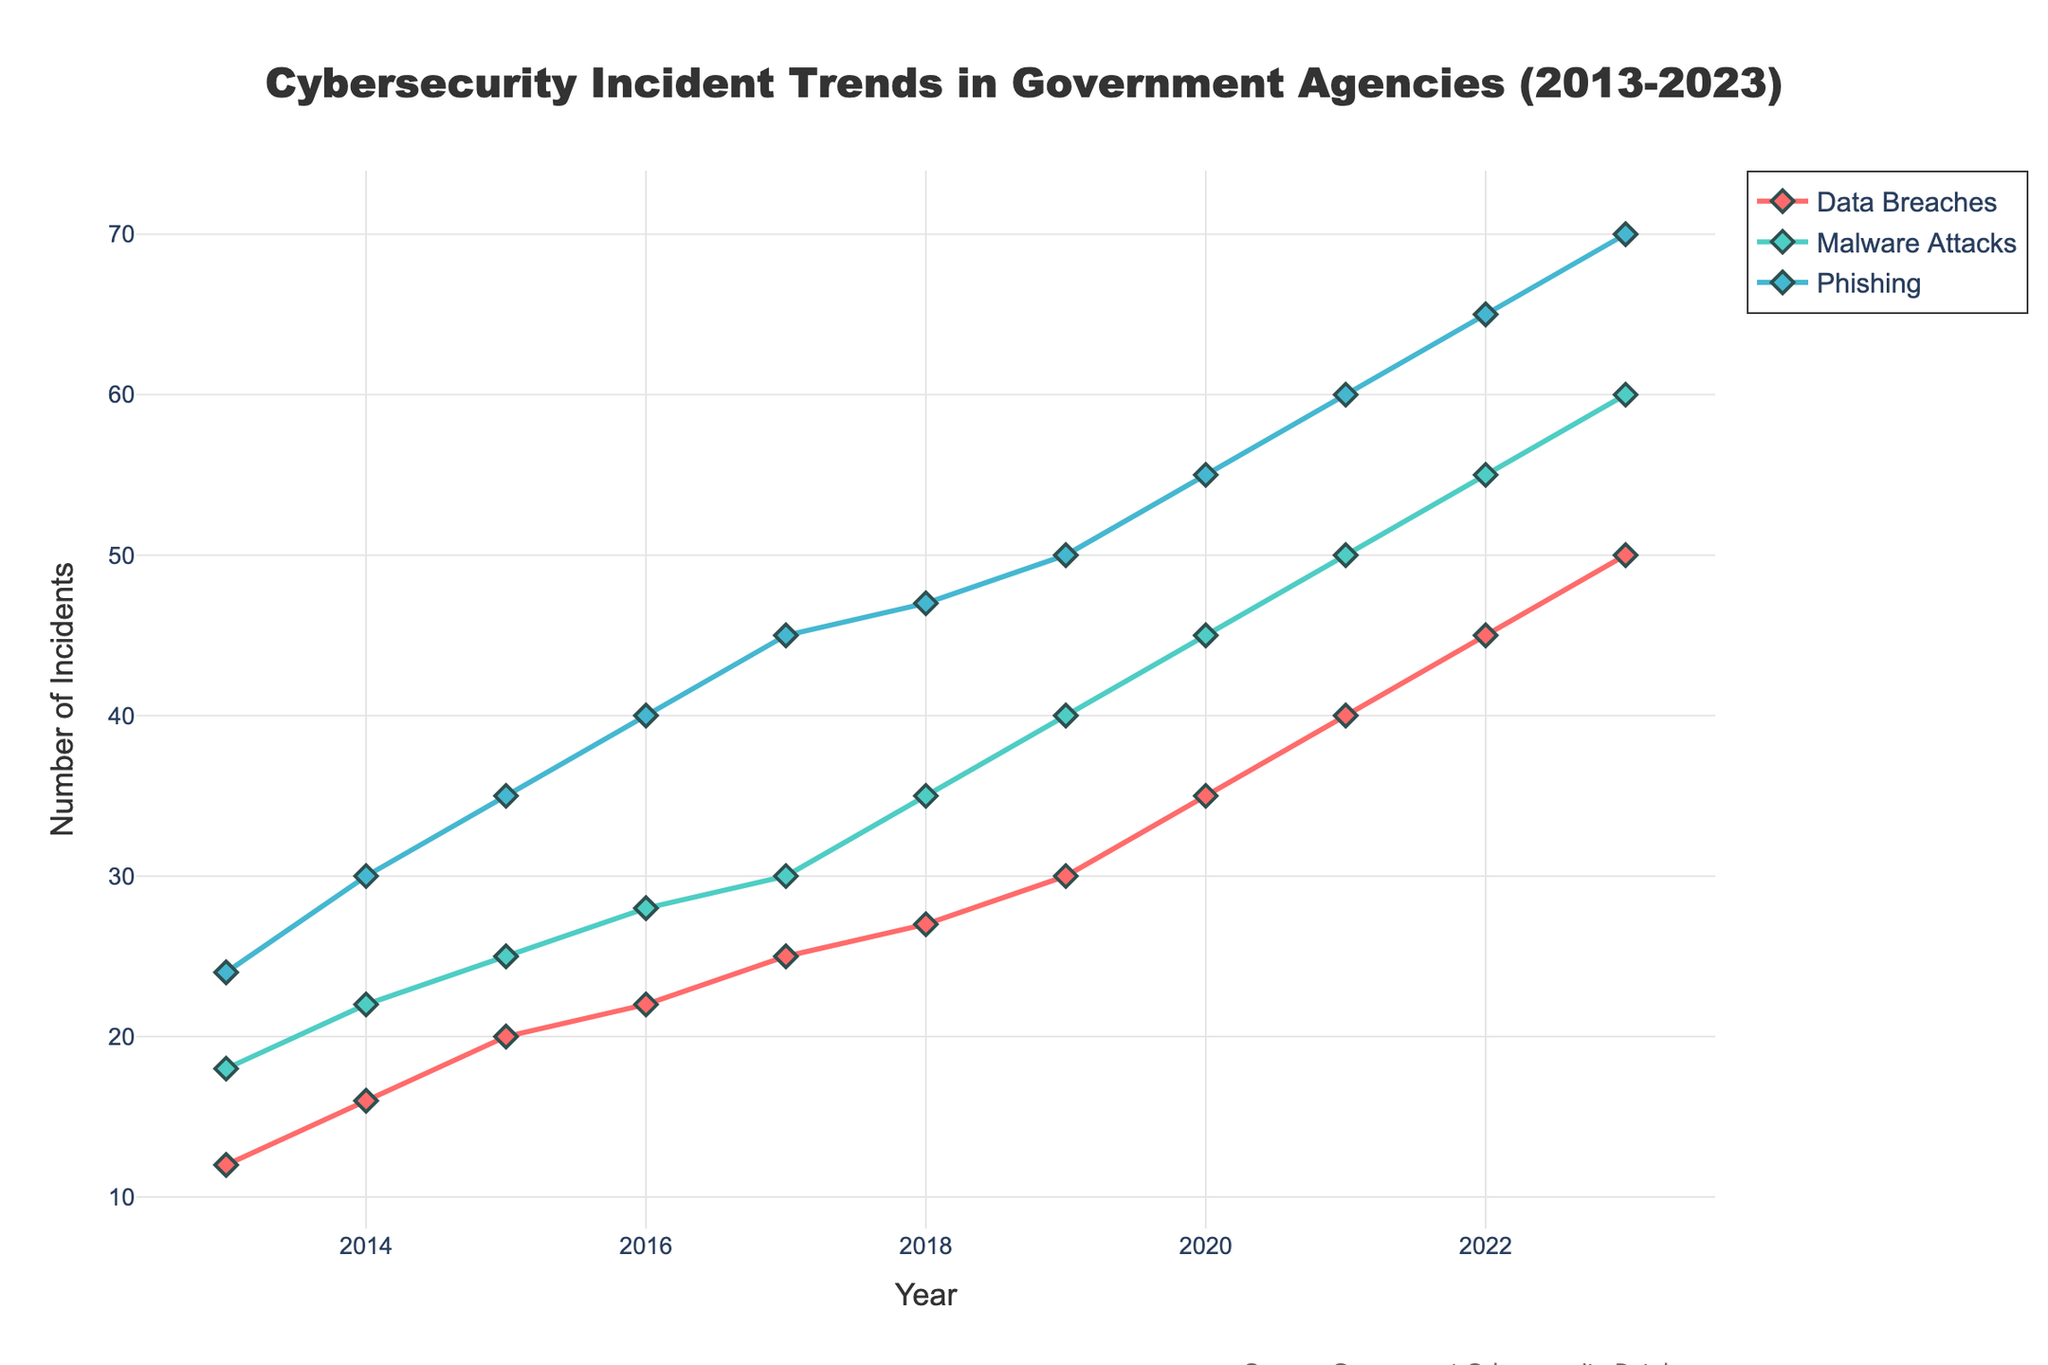Which type of incident had the highest number of events in 2023? The plot shows the trend lines and markers for each incident type. By looking at the data points for 2023, Phishing has the highest count at 70 incidents.
Answer: Phishing What is the general trend for Data Breaches from 2013 to 2023? Observing the Data Breach trend line, it shows a consistent upward trend, starting from 12 incidents in 2013 and increasing to 50 incidents in 2023.
Answer: Increasing Between 2018 and 2020, which type of incident saw the largest increase? To determine the largest increase, subtract the number of incidents in 2018 from that in 2020 for each type and compare. Phishing increased from 47 to 55 (an increase of 8), Malware Attacks from 35 to 45 (an increase of 10), and Data Breaches from 27 to 35 (an increase of 8). Malware Attacks showed the largest increase with 10 incidents.
Answer: Malware Attacks What were the number of Malware Attacks in 2015 and 2020? By checking the plot at the respective years, Malware Attacks were 25 in 2015 and 45 in 2020.
Answer: 25 in 2015 and 45 in 2020 How has the number of Phishing incidents changed from 2013 to 2023? Observing the Phishing trend line, there is a significant increase from 24 incidents in 2013 up to 70 incidents in 2023.
Answer: Increased Which year saw the most significant overall increase in incidents for all types combined? To find the year with the most significant increase, calculate the yearly difference for all incidents and sum them up. From 2019 to 2020, Data Breaches increased by 5, Malware Attacks by 5, and Phishing by 5. The total increase is 15 between 2019 and 2020.
Answer: 2019 to 2020 Compare the number of Data Breaches and Malware Attacks in 2017. Which one is higher? In 2017, Data Breaches are 25 and Malware Attacks are 30.
Answer: Malware Attacks How did the number of phishing incidents vary across the decade? By analyzing the Phishing incident line, there is a steady and significant increase from 24 in 2013 to 70 in 2023.
Answer: Increased Which type of incident had the closest number of events in 2020? In 2020, Phishing incidents were 55, Malware Attacks 45, and Data Breaches 35. The incidents with closest numbers are Malware Attacks and Phishing, having a difference of 10.
Answer: Malware Attacks and Phishing What is the difference in the number of Data Breaches between 2015 and 2023? Subtract the number of Data Breaches in 2015 (20) from that in 2023 (50): 50 - 20 = 30.
Answer: 30 